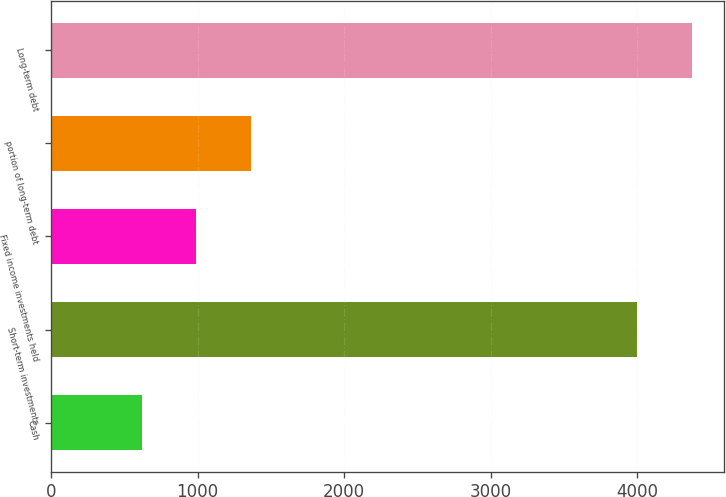Convert chart. <chart><loc_0><loc_0><loc_500><loc_500><bar_chart><fcel>Cash<fcel>Short-term investments<fcel>Fixed income investments held<fcel>portion of long-term debt<fcel>Long-term debt<nl><fcel>617<fcel>3999<fcel>990.8<fcel>1364.6<fcel>4372.8<nl></chart> 